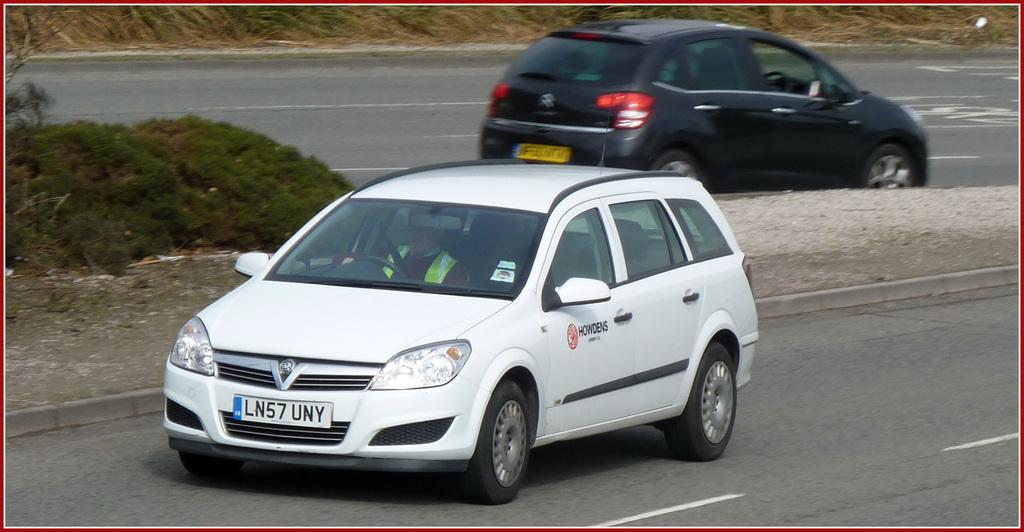<image>
Summarize the visual content of the image. A white station wagon with the Howden logo drives down a road. 